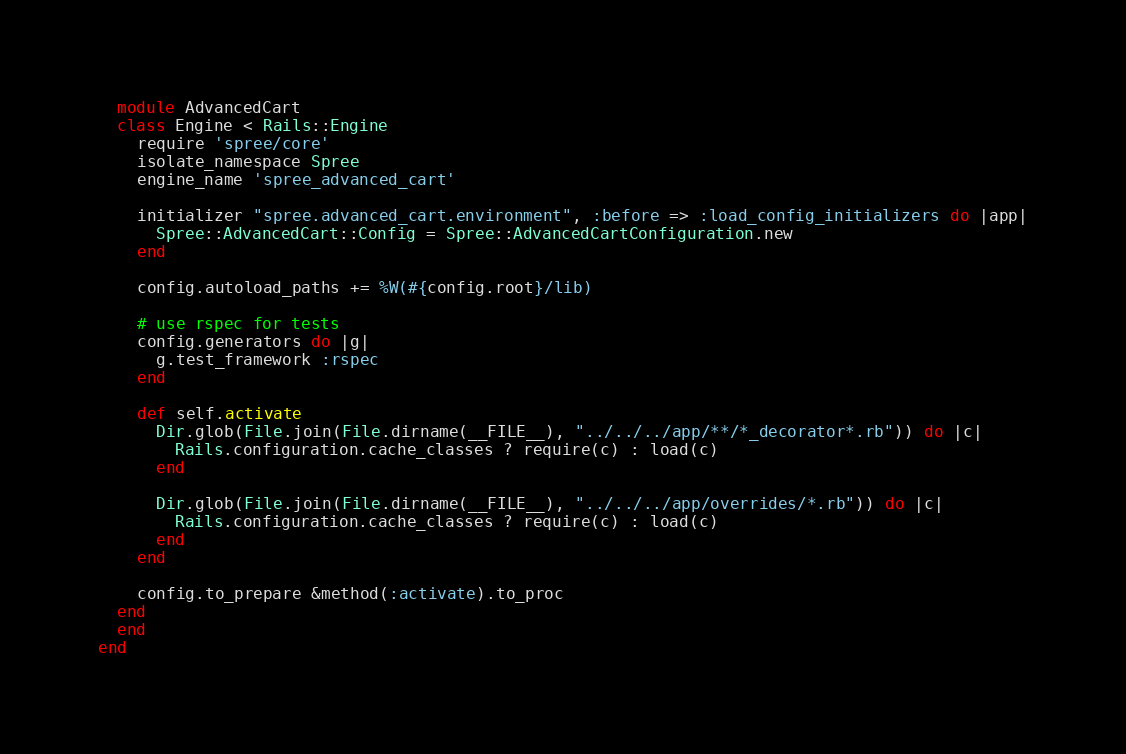<code> <loc_0><loc_0><loc_500><loc_500><_Ruby_>  module AdvancedCart
  class Engine < Rails::Engine
    require 'spree/core'
    isolate_namespace Spree
    engine_name 'spree_advanced_cart'

    initializer "spree.advanced_cart.environment", :before => :load_config_initializers do |app|
      Spree::AdvancedCart::Config = Spree::AdvancedCartConfiguration.new
    end

    config.autoload_paths += %W(#{config.root}/lib)

    # use rspec for tests
    config.generators do |g|
      g.test_framework :rspec
    end

    def self.activate
      Dir.glob(File.join(File.dirname(__FILE__), "../../../app/**/*_decorator*.rb")) do |c|
        Rails.configuration.cache_classes ? require(c) : load(c)
      end

      Dir.glob(File.join(File.dirname(__FILE__), "../../../app/overrides/*.rb")) do |c|
        Rails.configuration.cache_classes ? require(c) : load(c)
      end
    end

    config.to_prepare &method(:activate).to_proc
  end
  end
end
</code> 